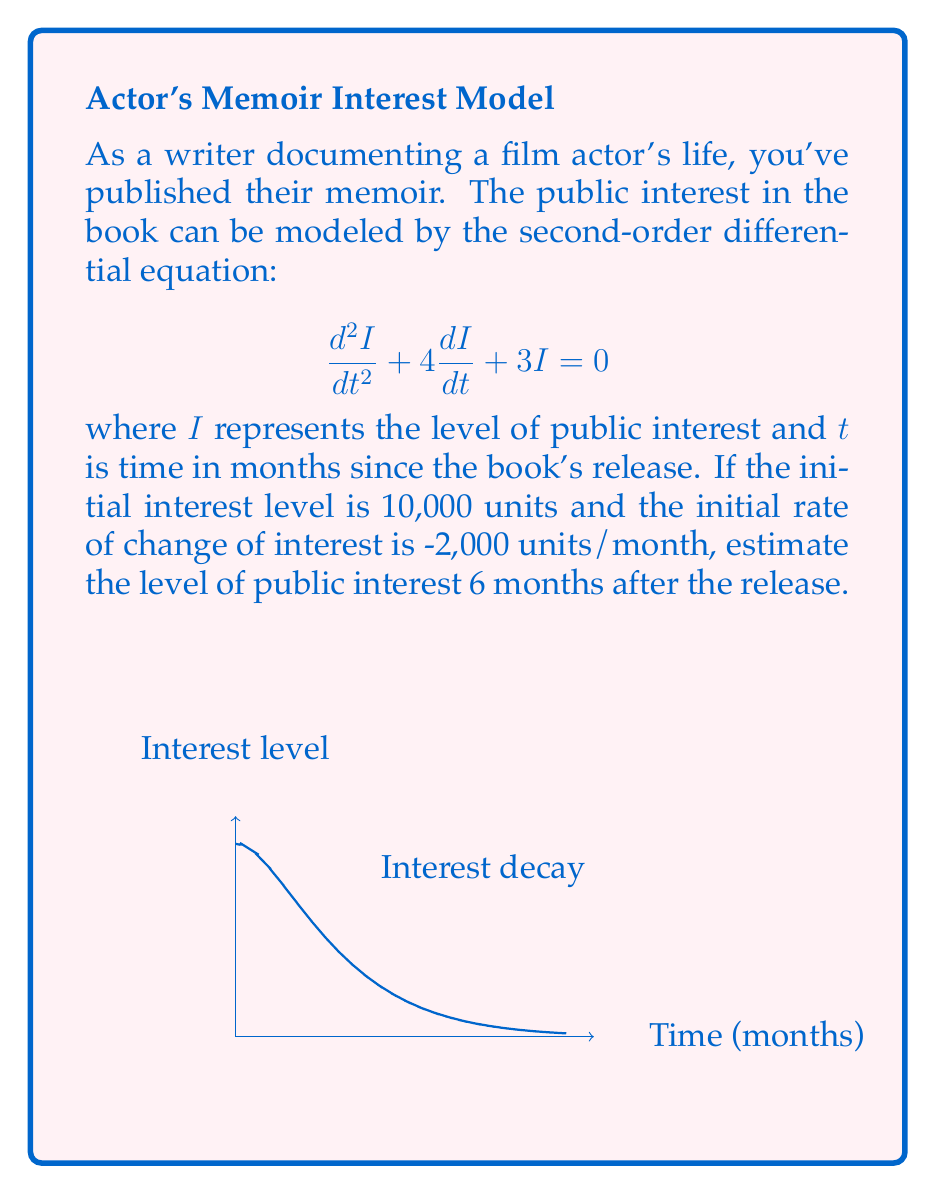Solve this math problem. 1) The characteristic equation for this differential equation is:
   $$r^2 + 4r + 3 = 0$$

2) Solving this equation:
   $$(r+1)(r+3) = 0$$
   $$r_1 = -1, r_2 = -3$$

3) The general solution is:
   $$I(t) = c_1e^{-t} + c_2e^{-3t}$$

4) Given initial conditions:
   $I(0) = 10000$ and $I'(0) = -2000$

5) Using $I(0) = 10000$:
   $$10000 = c_1 + c_2$$

6) Differentiating $I(t)$:
   $$I'(t) = -c_1e^{-t} - 3c_2e^{-3t}$$
   
   Using $I'(0) = -2000$:
   $$-2000 = -c_1 - 3c_2$$

7) Solving these equations:
   $$c_1 = 10000, c_2 = 0$$

8) Therefore, the particular solution is:
   $$I(t) = 10000e^{-t}$$

9) To find $I(6)$:
   $$I(6) = 10000e^{-6} \approx 248.6$$
Answer: 248.6 units 